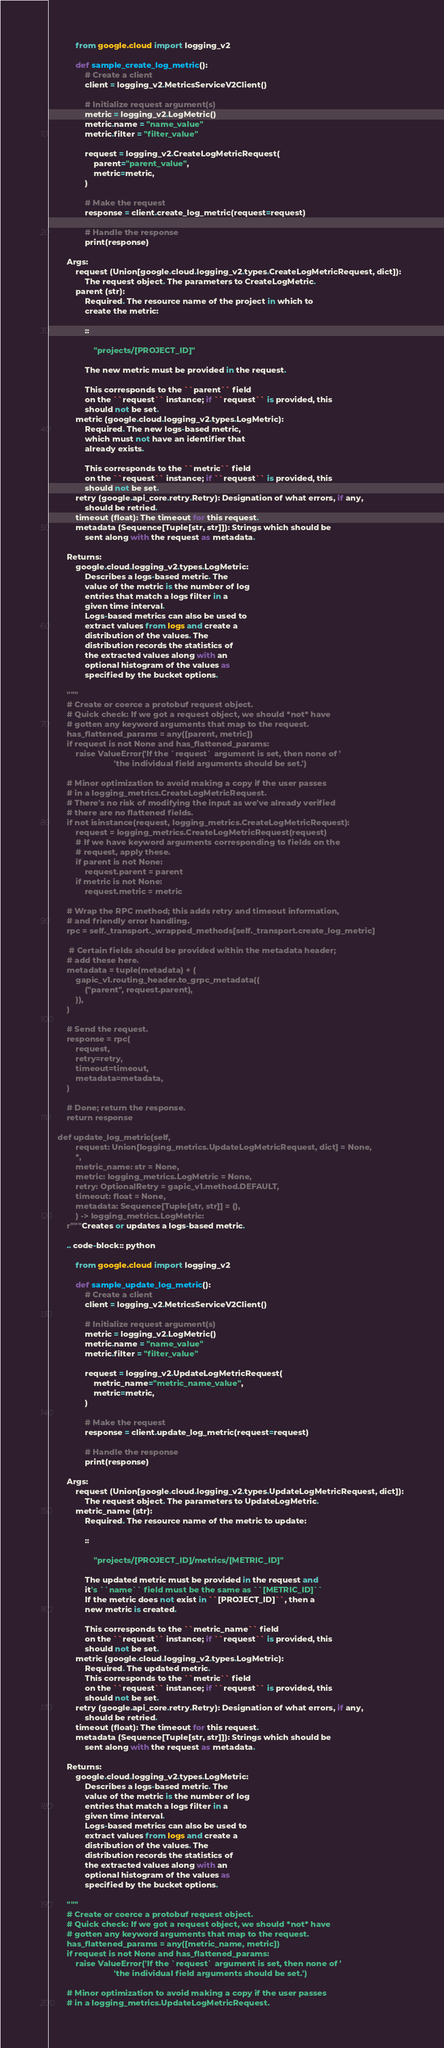Convert code to text. <code><loc_0><loc_0><loc_500><loc_500><_Python_>
            from google.cloud import logging_v2

            def sample_create_log_metric():
                # Create a client
                client = logging_v2.MetricsServiceV2Client()

                # Initialize request argument(s)
                metric = logging_v2.LogMetric()
                metric.name = "name_value"
                metric.filter = "filter_value"

                request = logging_v2.CreateLogMetricRequest(
                    parent="parent_value",
                    metric=metric,
                )

                # Make the request
                response = client.create_log_metric(request=request)

                # Handle the response
                print(response)

        Args:
            request (Union[google.cloud.logging_v2.types.CreateLogMetricRequest, dict]):
                The request object. The parameters to CreateLogMetric.
            parent (str):
                Required. The resource name of the project in which to
                create the metric:

                ::

                    "projects/[PROJECT_ID]"

                The new metric must be provided in the request.

                This corresponds to the ``parent`` field
                on the ``request`` instance; if ``request`` is provided, this
                should not be set.
            metric (google.cloud.logging_v2.types.LogMetric):
                Required. The new logs-based metric,
                which must not have an identifier that
                already exists.

                This corresponds to the ``metric`` field
                on the ``request`` instance; if ``request`` is provided, this
                should not be set.
            retry (google.api_core.retry.Retry): Designation of what errors, if any,
                should be retried.
            timeout (float): The timeout for this request.
            metadata (Sequence[Tuple[str, str]]): Strings which should be
                sent along with the request as metadata.

        Returns:
            google.cloud.logging_v2.types.LogMetric:
                Describes a logs-based metric. The
                value of the metric is the number of log
                entries that match a logs filter in a
                given time interval.
                Logs-based metrics can also be used to
                extract values from logs and create a
                distribution of the values. The
                distribution records the statistics of
                the extracted values along with an
                optional histogram of the values as
                specified by the bucket options.

        """
        # Create or coerce a protobuf request object.
        # Quick check: If we got a request object, we should *not* have
        # gotten any keyword arguments that map to the request.
        has_flattened_params = any([parent, metric])
        if request is not None and has_flattened_params:
            raise ValueError('If the `request` argument is set, then none of '
                             'the individual field arguments should be set.')

        # Minor optimization to avoid making a copy if the user passes
        # in a logging_metrics.CreateLogMetricRequest.
        # There's no risk of modifying the input as we've already verified
        # there are no flattened fields.
        if not isinstance(request, logging_metrics.CreateLogMetricRequest):
            request = logging_metrics.CreateLogMetricRequest(request)
            # If we have keyword arguments corresponding to fields on the
            # request, apply these.
            if parent is not None:
                request.parent = parent
            if metric is not None:
                request.metric = metric

        # Wrap the RPC method; this adds retry and timeout information,
        # and friendly error handling.
        rpc = self._transport._wrapped_methods[self._transport.create_log_metric]

         # Certain fields should be provided within the metadata header;
        # add these here.
        metadata = tuple(metadata) + (
            gapic_v1.routing_header.to_grpc_metadata((
                ("parent", request.parent),
            )),
        )

        # Send the request.
        response = rpc(
            request,
            retry=retry,
            timeout=timeout,
            metadata=metadata,
        )

        # Done; return the response.
        return response

    def update_log_metric(self,
            request: Union[logging_metrics.UpdateLogMetricRequest, dict] = None,
            *,
            metric_name: str = None,
            metric: logging_metrics.LogMetric = None,
            retry: OptionalRetry = gapic_v1.method.DEFAULT,
            timeout: float = None,
            metadata: Sequence[Tuple[str, str]] = (),
            ) -> logging_metrics.LogMetric:
        r"""Creates or updates a logs-based metric.

        .. code-block:: python

            from google.cloud import logging_v2

            def sample_update_log_metric():
                # Create a client
                client = logging_v2.MetricsServiceV2Client()

                # Initialize request argument(s)
                metric = logging_v2.LogMetric()
                metric.name = "name_value"
                metric.filter = "filter_value"

                request = logging_v2.UpdateLogMetricRequest(
                    metric_name="metric_name_value",
                    metric=metric,
                )

                # Make the request
                response = client.update_log_metric(request=request)

                # Handle the response
                print(response)

        Args:
            request (Union[google.cloud.logging_v2.types.UpdateLogMetricRequest, dict]):
                The request object. The parameters to UpdateLogMetric.
            metric_name (str):
                Required. The resource name of the metric to update:

                ::

                    "projects/[PROJECT_ID]/metrics/[METRIC_ID]"

                The updated metric must be provided in the request and
                it's ``name`` field must be the same as ``[METRIC_ID]``
                If the metric does not exist in ``[PROJECT_ID]``, then a
                new metric is created.

                This corresponds to the ``metric_name`` field
                on the ``request`` instance; if ``request`` is provided, this
                should not be set.
            metric (google.cloud.logging_v2.types.LogMetric):
                Required. The updated metric.
                This corresponds to the ``metric`` field
                on the ``request`` instance; if ``request`` is provided, this
                should not be set.
            retry (google.api_core.retry.Retry): Designation of what errors, if any,
                should be retried.
            timeout (float): The timeout for this request.
            metadata (Sequence[Tuple[str, str]]): Strings which should be
                sent along with the request as metadata.

        Returns:
            google.cloud.logging_v2.types.LogMetric:
                Describes a logs-based metric. The
                value of the metric is the number of log
                entries that match a logs filter in a
                given time interval.
                Logs-based metrics can also be used to
                extract values from logs and create a
                distribution of the values. The
                distribution records the statistics of
                the extracted values along with an
                optional histogram of the values as
                specified by the bucket options.

        """
        # Create or coerce a protobuf request object.
        # Quick check: If we got a request object, we should *not* have
        # gotten any keyword arguments that map to the request.
        has_flattened_params = any([metric_name, metric])
        if request is not None and has_flattened_params:
            raise ValueError('If the `request` argument is set, then none of '
                             'the individual field arguments should be set.')

        # Minor optimization to avoid making a copy if the user passes
        # in a logging_metrics.UpdateLogMetricRequest.</code> 